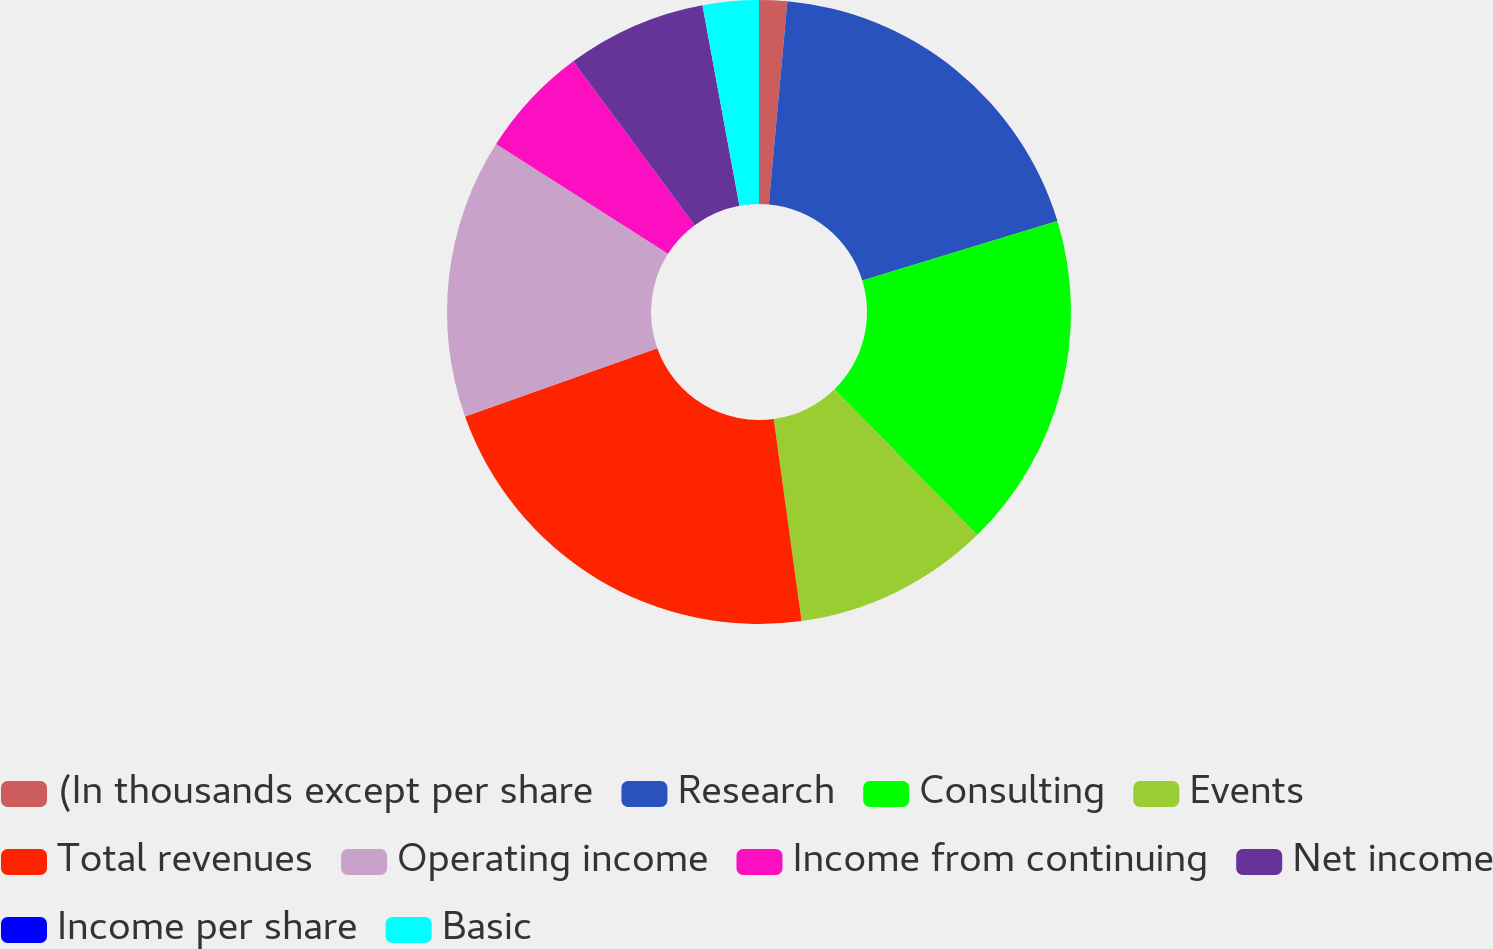<chart> <loc_0><loc_0><loc_500><loc_500><pie_chart><fcel>(In thousands except per share<fcel>Research<fcel>Consulting<fcel>Events<fcel>Total revenues<fcel>Operating income<fcel>Income from continuing<fcel>Net income<fcel>Income per share<fcel>Basic<nl><fcel>1.45%<fcel>18.84%<fcel>17.39%<fcel>10.14%<fcel>21.74%<fcel>14.49%<fcel>5.8%<fcel>7.25%<fcel>0.0%<fcel>2.9%<nl></chart> 